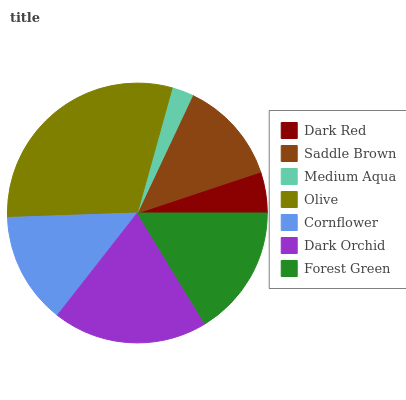Is Medium Aqua the minimum?
Answer yes or no. Yes. Is Olive the maximum?
Answer yes or no. Yes. Is Saddle Brown the minimum?
Answer yes or no. No. Is Saddle Brown the maximum?
Answer yes or no. No. Is Saddle Brown greater than Dark Red?
Answer yes or no. Yes. Is Dark Red less than Saddle Brown?
Answer yes or no. Yes. Is Dark Red greater than Saddle Brown?
Answer yes or no. No. Is Saddle Brown less than Dark Red?
Answer yes or no. No. Is Cornflower the high median?
Answer yes or no. Yes. Is Cornflower the low median?
Answer yes or no. Yes. Is Dark Orchid the high median?
Answer yes or no. No. Is Forest Green the low median?
Answer yes or no. No. 